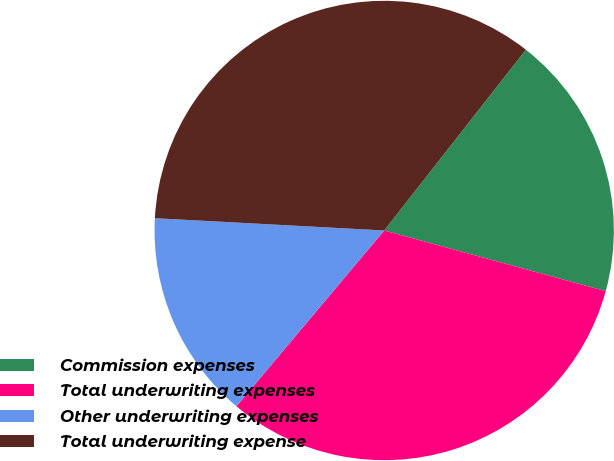<chart> <loc_0><loc_0><loc_500><loc_500><pie_chart><fcel>Commission expenses<fcel>Total underwriting expenses<fcel>Other underwriting expenses<fcel>Total underwriting expense<nl><fcel>18.68%<fcel>31.87%<fcel>14.73%<fcel>34.73%<nl></chart> 